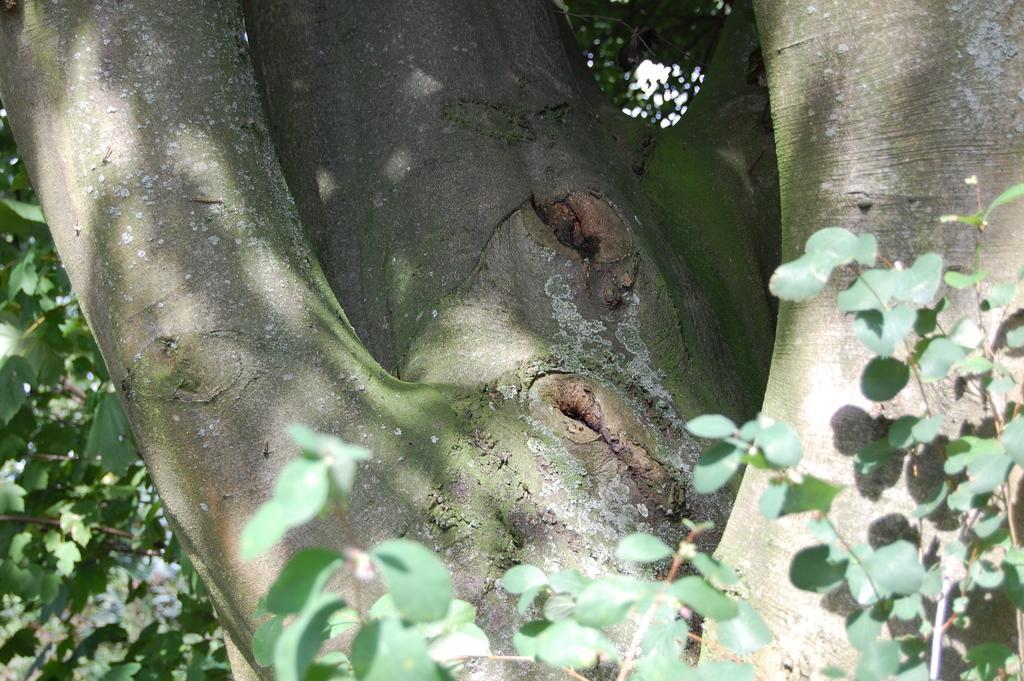In one or two sentences, can you explain what this image depicts? In this image we can see a bark of a tree and some leaves. 